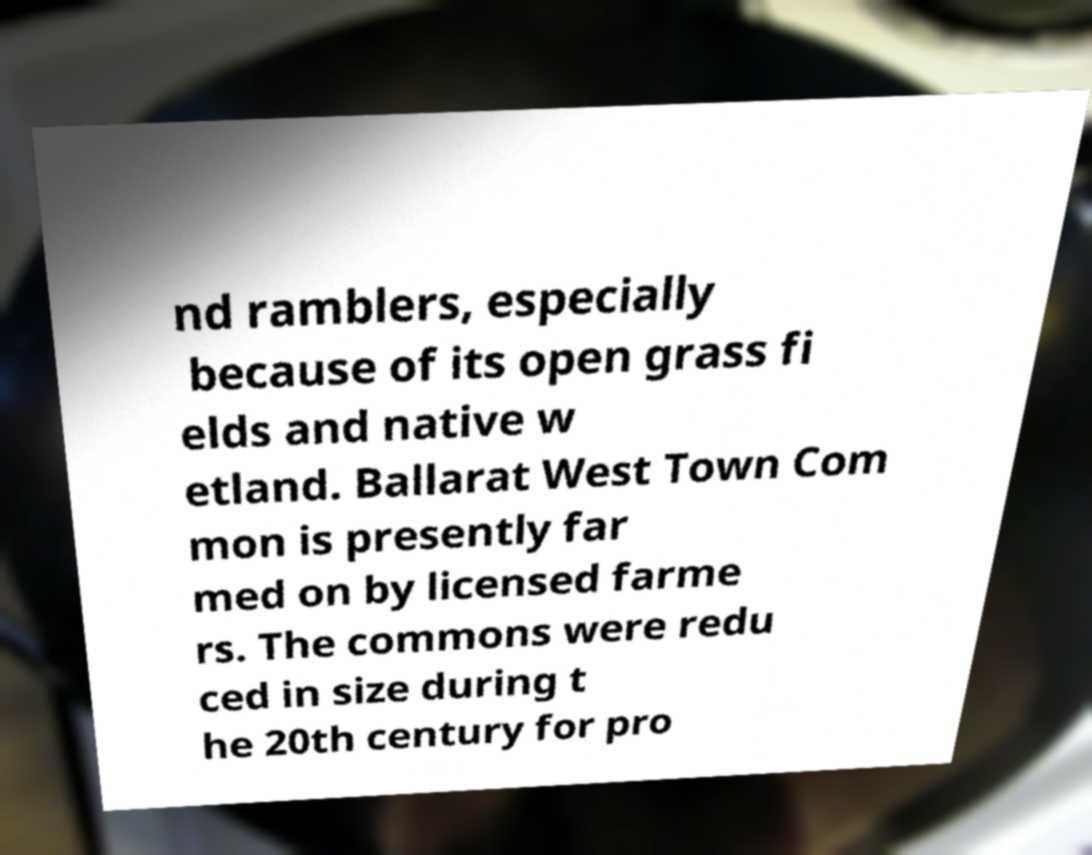I need the written content from this picture converted into text. Can you do that? nd ramblers, especially because of its open grass fi elds and native w etland. Ballarat West Town Com mon is presently far med on by licensed farme rs. The commons were redu ced in size during t he 20th century for pro 